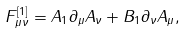Convert formula to latex. <formula><loc_0><loc_0><loc_500><loc_500>F ^ { [ 1 ] } _ { \mu \nu } = A _ { 1 } \partial _ { \mu } A _ { \nu } + B _ { 1 } \partial _ { \nu } A _ { \mu } ,</formula> 